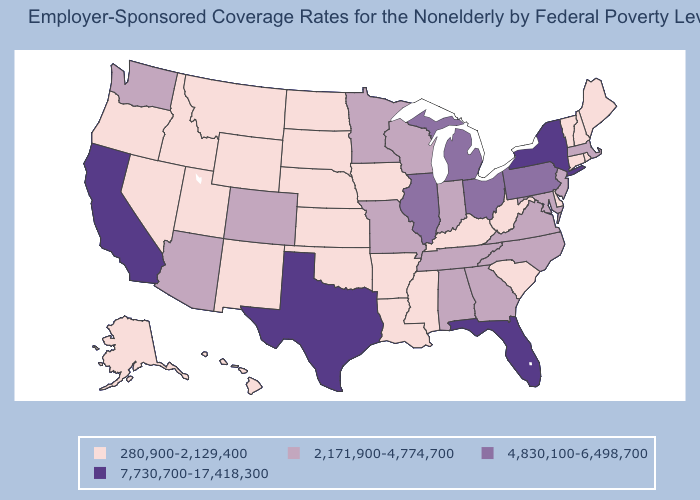Which states have the lowest value in the USA?
Give a very brief answer. Alaska, Arkansas, Connecticut, Delaware, Hawaii, Idaho, Iowa, Kansas, Kentucky, Louisiana, Maine, Mississippi, Montana, Nebraska, Nevada, New Hampshire, New Mexico, North Dakota, Oklahoma, Oregon, Rhode Island, South Carolina, South Dakota, Utah, Vermont, West Virginia, Wyoming. What is the value of Wisconsin?
Answer briefly. 2,171,900-4,774,700. What is the value of Maine?
Give a very brief answer. 280,900-2,129,400. Among the states that border Arizona , which have the lowest value?
Keep it brief. Nevada, New Mexico, Utah. Name the states that have a value in the range 7,730,700-17,418,300?
Short answer required. California, Florida, New York, Texas. Does Nevada have a lower value than Minnesota?
Write a very short answer. Yes. What is the highest value in the South ?
Short answer required. 7,730,700-17,418,300. Name the states that have a value in the range 4,830,100-6,498,700?
Concise answer only. Illinois, Michigan, Ohio, Pennsylvania. Among the states that border Idaho , does Wyoming have the highest value?
Answer briefly. No. What is the value of Oregon?
Short answer required. 280,900-2,129,400. What is the highest value in states that border California?
Quick response, please. 2,171,900-4,774,700. Is the legend a continuous bar?
Write a very short answer. No. Name the states that have a value in the range 280,900-2,129,400?
Keep it brief. Alaska, Arkansas, Connecticut, Delaware, Hawaii, Idaho, Iowa, Kansas, Kentucky, Louisiana, Maine, Mississippi, Montana, Nebraska, Nevada, New Hampshire, New Mexico, North Dakota, Oklahoma, Oregon, Rhode Island, South Carolina, South Dakota, Utah, Vermont, West Virginia, Wyoming. Does the first symbol in the legend represent the smallest category?
Short answer required. Yes. Which states have the lowest value in the South?
Answer briefly. Arkansas, Delaware, Kentucky, Louisiana, Mississippi, Oklahoma, South Carolina, West Virginia. 